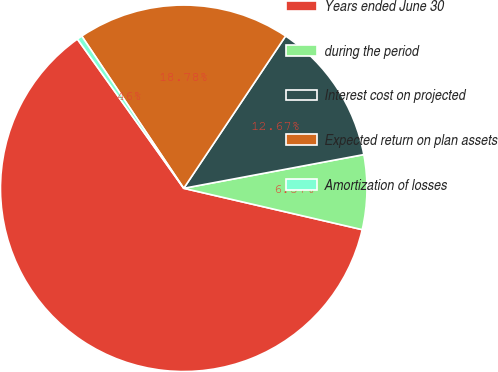Convert chart to OTSL. <chart><loc_0><loc_0><loc_500><loc_500><pie_chart><fcel>Years ended June 30<fcel>during the period<fcel>Interest cost on projected<fcel>Expected return on plan assets<fcel>Amortization of losses<nl><fcel>61.53%<fcel>6.57%<fcel>12.67%<fcel>18.78%<fcel>0.46%<nl></chart> 